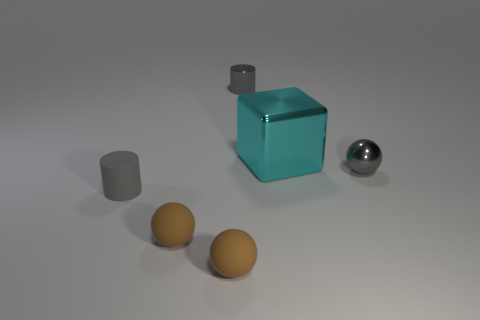Subtract all yellow cylinders. Subtract all gray cubes. How many cylinders are left? 2 Add 2 matte cylinders. How many objects exist? 8 Subtract all cylinders. How many objects are left? 4 Add 1 gray metal cylinders. How many gray metal cylinders exist? 2 Subtract 2 gray cylinders. How many objects are left? 4 Subtract all cyan matte balls. Subtract all tiny cylinders. How many objects are left? 4 Add 3 gray metal cylinders. How many gray metal cylinders are left? 4 